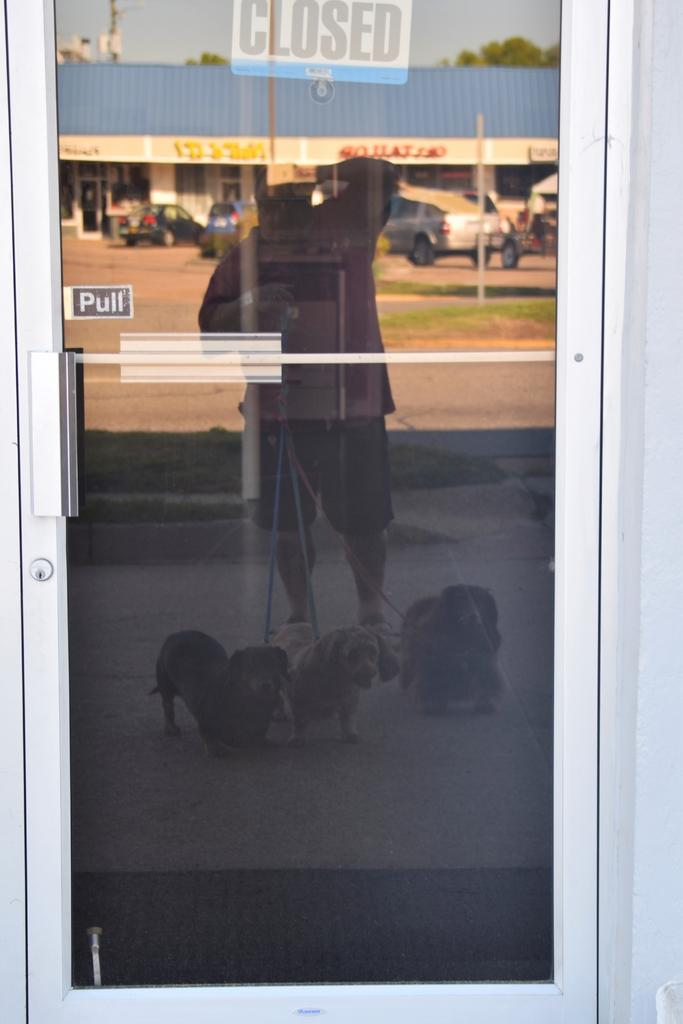What is located in the foreground of the image? There is a glass door in the foreground of the image. What can be seen in the reflection of the glass door? A man holding dogs is reflected in the glass door. What can be seen in the background of the image? There are cars, stores, and trees in the background of the image. What type of trade is being conducted in the image? There is no indication of any trade being conducted in the image. How many cents are visible in the image? There are no cents present in the image. 